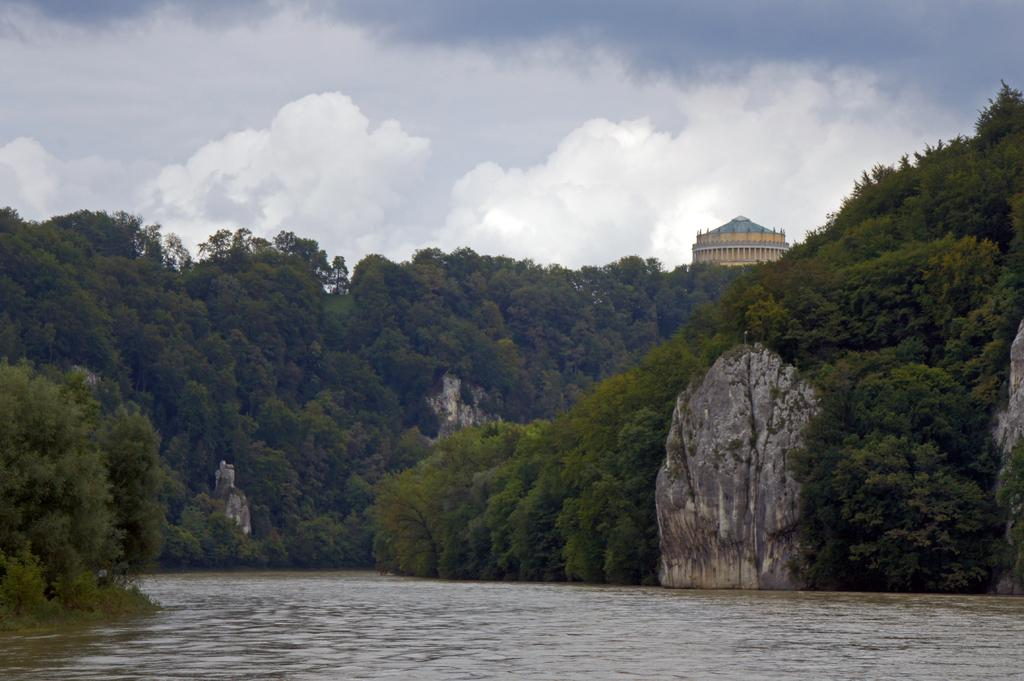What is the primary element in the image? There is water in the image. What other objects or features can be seen in the image? There are rocks in the image. What can be seen in the background of the image? There are trees and a building in the background of the image. How would you describe the weather in the image? The sky is cloudy in the image. Where is the pig located in the image? There is no pig present in the image. What type of order is being followed by the trees in the image? The trees in the image are not following any specific order; they are simply part of the natural landscape. 